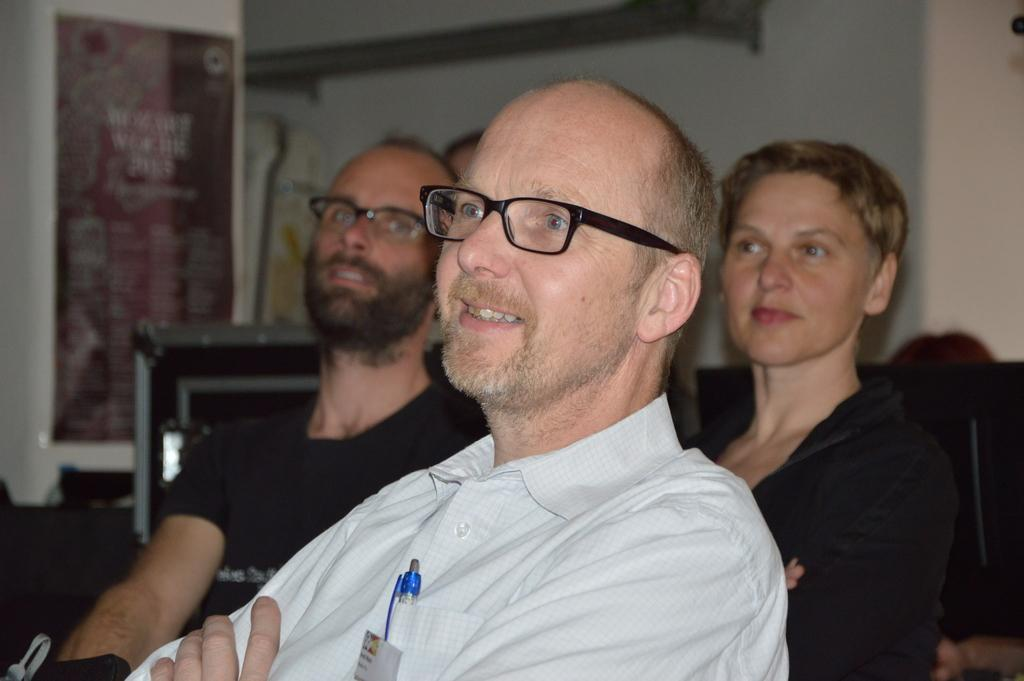Who or what is present in the image? There are people in the image. What can be seen in the background of the image? There is a wall in the background of the image. Is there any text or writing visible in the image? Yes, there is a poster with some text in the image. How many stars can be seen in the image? There are no stars visible in the image. 